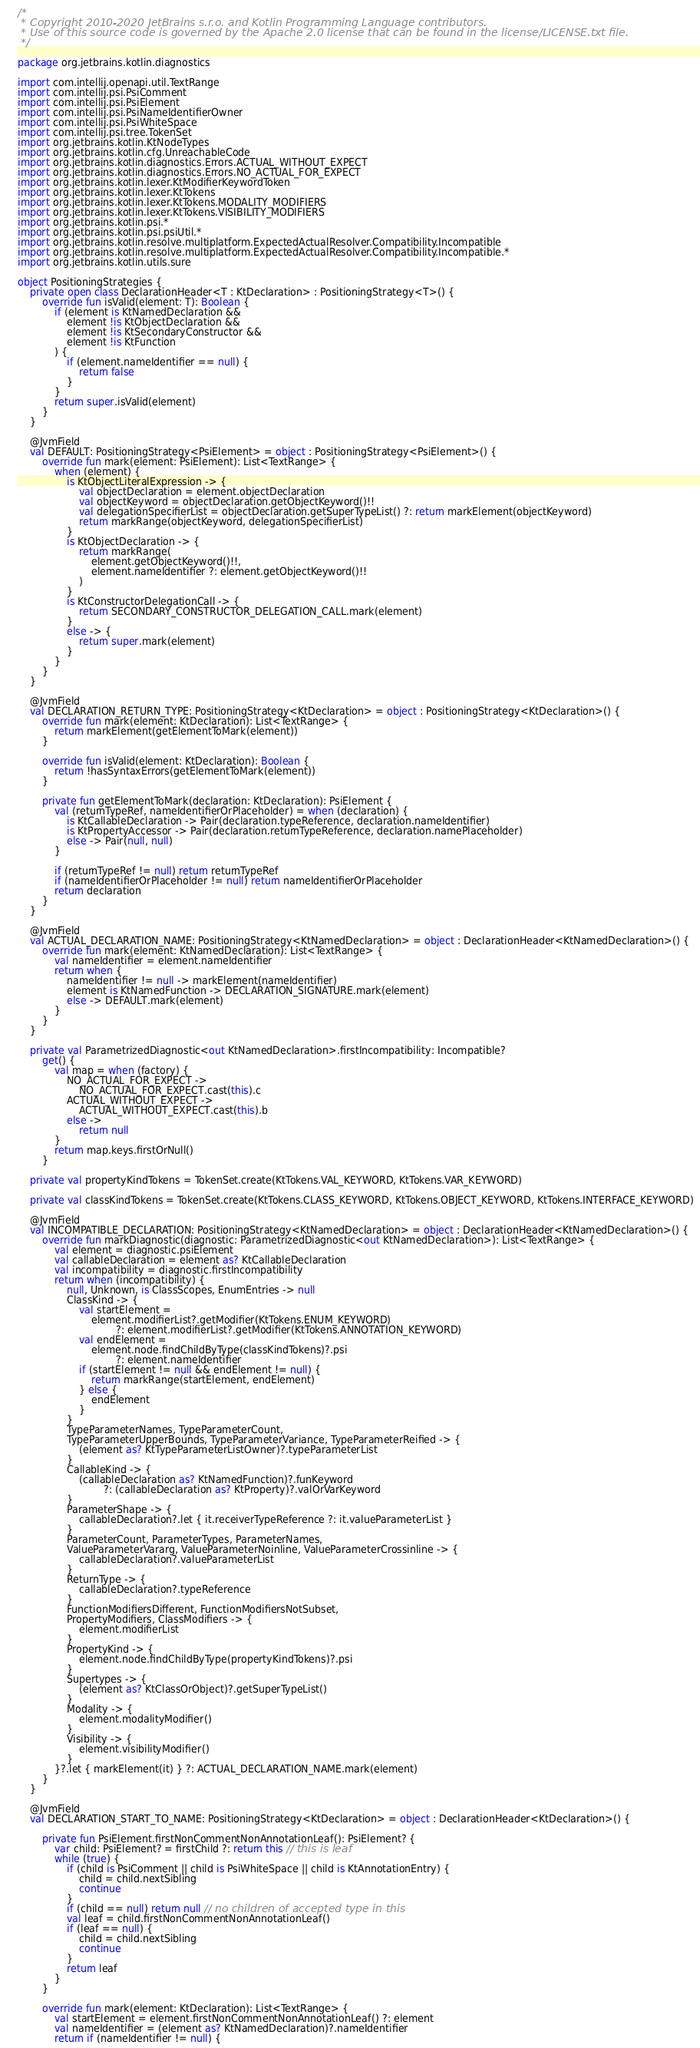<code> <loc_0><loc_0><loc_500><loc_500><_Kotlin_>/*
 * Copyright 2010-2020 JetBrains s.r.o. and Kotlin Programming Language contributors.
 * Use of this source code is governed by the Apache 2.0 license that can be found in the license/LICENSE.txt file.
 */

package org.jetbrains.kotlin.diagnostics

import com.intellij.openapi.util.TextRange
import com.intellij.psi.PsiComment
import com.intellij.psi.PsiElement
import com.intellij.psi.PsiNameIdentifierOwner
import com.intellij.psi.PsiWhiteSpace
import com.intellij.psi.tree.TokenSet
import org.jetbrains.kotlin.KtNodeTypes
import org.jetbrains.kotlin.cfg.UnreachableCode
import org.jetbrains.kotlin.diagnostics.Errors.ACTUAL_WITHOUT_EXPECT
import org.jetbrains.kotlin.diagnostics.Errors.NO_ACTUAL_FOR_EXPECT
import org.jetbrains.kotlin.lexer.KtModifierKeywordToken
import org.jetbrains.kotlin.lexer.KtTokens
import org.jetbrains.kotlin.lexer.KtTokens.MODALITY_MODIFIERS
import org.jetbrains.kotlin.lexer.KtTokens.VISIBILITY_MODIFIERS
import org.jetbrains.kotlin.psi.*
import org.jetbrains.kotlin.psi.psiUtil.*
import org.jetbrains.kotlin.resolve.multiplatform.ExpectedActualResolver.Compatibility.Incompatible
import org.jetbrains.kotlin.resolve.multiplatform.ExpectedActualResolver.Compatibility.Incompatible.*
import org.jetbrains.kotlin.utils.sure

object PositioningStrategies {
    private open class DeclarationHeader<T : KtDeclaration> : PositioningStrategy<T>() {
        override fun isValid(element: T): Boolean {
            if (element is KtNamedDeclaration &&
                element !is KtObjectDeclaration &&
                element !is KtSecondaryConstructor &&
                element !is KtFunction
            ) {
                if (element.nameIdentifier == null) {
                    return false
                }
            }
            return super.isValid(element)
        }
    }

    @JvmField
    val DEFAULT: PositioningStrategy<PsiElement> = object : PositioningStrategy<PsiElement>() {
        override fun mark(element: PsiElement): List<TextRange> {
            when (element) {
                is KtObjectLiteralExpression -> {
                    val objectDeclaration = element.objectDeclaration
                    val objectKeyword = objectDeclaration.getObjectKeyword()!!
                    val delegationSpecifierList = objectDeclaration.getSuperTypeList() ?: return markElement(objectKeyword)
                    return markRange(objectKeyword, delegationSpecifierList)
                }
                is KtObjectDeclaration -> {
                    return markRange(
                        element.getObjectKeyword()!!,
                        element.nameIdentifier ?: element.getObjectKeyword()!!
                    )
                }
                is KtConstructorDelegationCall -> {
                    return SECONDARY_CONSTRUCTOR_DELEGATION_CALL.mark(element)
                }
                else -> {
                    return super.mark(element)
                }
            }
        }
    }

    @JvmField
    val DECLARATION_RETURN_TYPE: PositioningStrategy<KtDeclaration> = object : PositioningStrategy<KtDeclaration>() {
        override fun mark(element: KtDeclaration): List<TextRange> {
            return markElement(getElementToMark(element))
        }

        override fun isValid(element: KtDeclaration): Boolean {
            return !hasSyntaxErrors(getElementToMark(element))
        }

        private fun getElementToMark(declaration: KtDeclaration): PsiElement {
            val (returnTypeRef, nameIdentifierOrPlaceholder) = when (declaration) {
                is KtCallableDeclaration -> Pair(declaration.typeReference, declaration.nameIdentifier)
                is KtPropertyAccessor -> Pair(declaration.returnTypeReference, declaration.namePlaceholder)
                else -> Pair(null, null)
            }

            if (returnTypeRef != null) return returnTypeRef
            if (nameIdentifierOrPlaceholder != null) return nameIdentifierOrPlaceholder
            return declaration
        }
    }

    @JvmField
    val ACTUAL_DECLARATION_NAME: PositioningStrategy<KtNamedDeclaration> = object : DeclarationHeader<KtNamedDeclaration>() {
        override fun mark(element: KtNamedDeclaration): List<TextRange> {
            val nameIdentifier = element.nameIdentifier
            return when {
                nameIdentifier != null -> markElement(nameIdentifier)
                element is KtNamedFunction -> DECLARATION_SIGNATURE.mark(element)
                else -> DEFAULT.mark(element)
            }
        }
    }

    private val ParametrizedDiagnostic<out KtNamedDeclaration>.firstIncompatibility: Incompatible?
        get() {
            val map = when (factory) {
                NO_ACTUAL_FOR_EXPECT ->
                    NO_ACTUAL_FOR_EXPECT.cast(this).c
                ACTUAL_WITHOUT_EXPECT ->
                    ACTUAL_WITHOUT_EXPECT.cast(this).b
                else ->
                    return null
            }
            return map.keys.firstOrNull()
        }

    private val propertyKindTokens = TokenSet.create(KtTokens.VAL_KEYWORD, KtTokens.VAR_KEYWORD)

    private val classKindTokens = TokenSet.create(KtTokens.CLASS_KEYWORD, KtTokens.OBJECT_KEYWORD, KtTokens.INTERFACE_KEYWORD)

    @JvmField
    val INCOMPATIBLE_DECLARATION: PositioningStrategy<KtNamedDeclaration> = object : DeclarationHeader<KtNamedDeclaration>() {
        override fun markDiagnostic(diagnostic: ParametrizedDiagnostic<out KtNamedDeclaration>): List<TextRange> {
            val element = diagnostic.psiElement
            val callableDeclaration = element as? KtCallableDeclaration
            val incompatibility = diagnostic.firstIncompatibility
            return when (incompatibility) {
                null, Unknown, is ClassScopes, EnumEntries -> null
                ClassKind -> {
                    val startElement =
                        element.modifierList?.getModifier(KtTokens.ENUM_KEYWORD)
                                ?: element.modifierList?.getModifier(KtTokens.ANNOTATION_KEYWORD)
                    val endElement =
                        element.node.findChildByType(classKindTokens)?.psi
                                ?: element.nameIdentifier
                    if (startElement != null && endElement != null) {
                        return markRange(startElement, endElement)
                    } else {
                        endElement
                    }
                }
                TypeParameterNames, TypeParameterCount,
                TypeParameterUpperBounds, TypeParameterVariance, TypeParameterReified -> {
                    (element as? KtTypeParameterListOwner)?.typeParameterList
                }
                CallableKind -> {
                    (callableDeclaration as? KtNamedFunction)?.funKeyword
                            ?: (callableDeclaration as? KtProperty)?.valOrVarKeyword
                }
                ParameterShape -> {
                    callableDeclaration?.let { it.receiverTypeReference ?: it.valueParameterList }
                }
                ParameterCount, ParameterTypes, ParameterNames,
                ValueParameterVararg, ValueParameterNoinline, ValueParameterCrossinline -> {
                    callableDeclaration?.valueParameterList
                }
                ReturnType -> {
                    callableDeclaration?.typeReference
                }
                FunctionModifiersDifferent, FunctionModifiersNotSubset,
                PropertyModifiers, ClassModifiers -> {
                    element.modifierList
                }
                PropertyKind -> {
                    element.node.findChildByType(propertyKindTokens)?.psi
                }
                Supertypes -> {
                    (element as? KtClassOrObject)?.getSuperTypeList()
                }
                Modality -> {
                    element.modalityModifier()
                }
                Visibility -> {
                    element.visibilityModifier()
                }
            }?.let { markElement(it) } ?: ACTUAL_DECLARATION_NAME.mark(element)
        }
    }

    @JvmField
    val DECLARATION_START_TO_NAME: PositioningStrategy<KtDeclaration> = object : DeclarationHeader<KtDeclaration>() {

        private fun PsiElement.firstNonCommentNonAnnotationLeaf(): PsiElement? {
            var child: PsiElement? = firstChild ?: return this // this is leaf
            while (true) {
                if (child is PsiComment || child is PsiWhiteSpace || child is KtAnnotationEntry) {
                    child = child.nextSibling
                    continue
                }
                if (child == null) return null // no children of accepted type in this
                val leaf = child.firstNonCommentNonAnnotationLeaf()
                if (leaf == null) {
                    child = child.nextSibling
                    continue
                }
                return leaf
            }
        }

        override fun mark(element: KtDeclaration): List<TextRange> {
            val startElement = element.firstNonCommentNonAnnotationLeaf() ?: element
            val nameIdentifier = (element as? KtNamedDeclaration)?.nameIdentifier
            return if (nameIdentifier != null) {</code> 